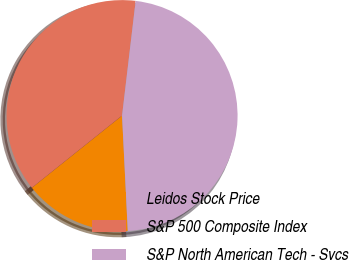Convert chart to OTSL. <chart><loc_0><loc_0><loc_500><loc_500><pie_chart><fcel>Leidos Stock Price<fcel>S&P 500 Composite Index<fcel>S&P North American Tech - Svcs<nl><fcel>15.05%<fcel>37.62%<fcel>47.34%<nl></chart> 